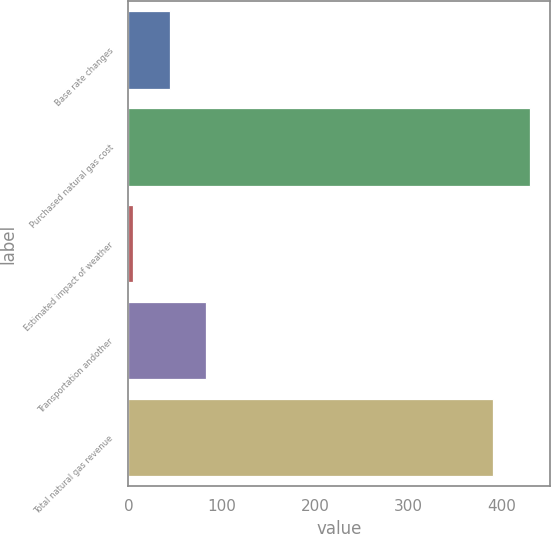<chart> <loc_0><loc_0><loc_500><loc_500><bar_chart><fcel>Base rate changes<fcel>Purchased natural gas cost<fcel>Estimated impact of weather<fcel>Transportation andother<fcel>Total natural gas revenue<nl><fcel>44.2<fcel>430.2<fcel>5<fcel>83.4<fcel>391<nl></chart> 